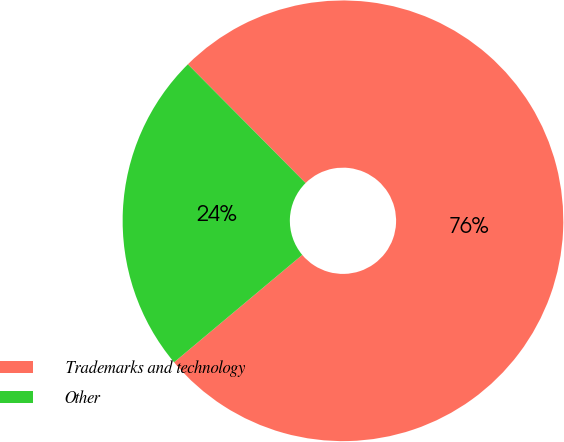<chart> <loc_0><loc_0><loc_500><loc_500><pie_chart><fcel>Trademarks and technology<fcel>Other<nl><fcel>76.33%<fcel>23.67%<nl></chart> 